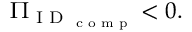<formula> <loc_0><loc_0><loc_500><loc_500>\Pi _ { I D _ { c o m p } } < 0 .</formula> 